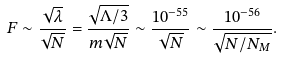<formula> <loc_0><loc_0><loc_500><loc_500>F \sim \frac { \sqrt { \lambda } } { \sqrt { N } } = \frac { \sqrt { \Lambda / 3 } } { m \sqrt { N } } \sim \frac { 1 0 ^ { - 5 5 } } { \sqrt { N } } \sim \frac { 1 0 ^ { - 5 6 } } { \sqrt { N / N _ { M } } } .</formula> 